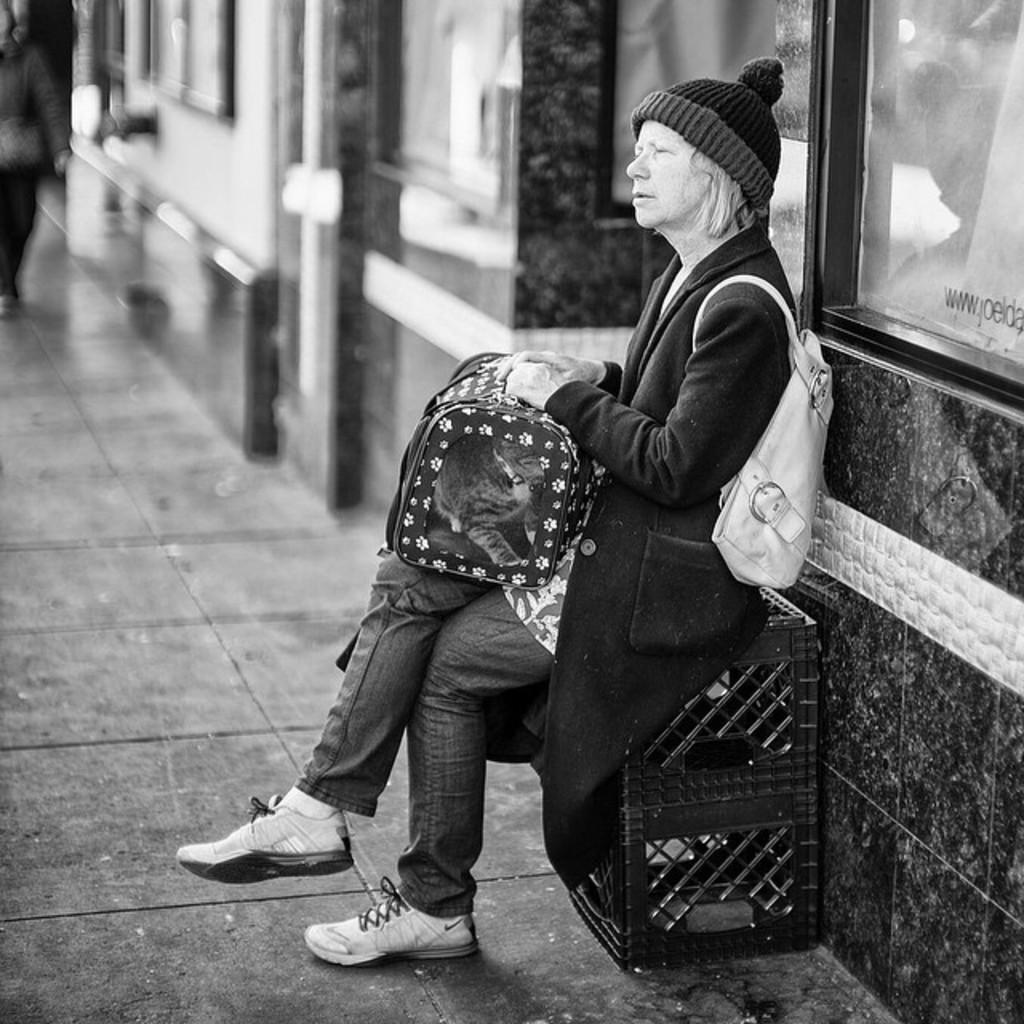Could you give a brief overview of what you see in this image? It is a black and white image and in this image we can see a woman wearing a bag and sitting on an object which is on the surface. In the background we can see the building. 